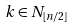Convert formula to latex. <formula><loc_0><loc_0><loc_500><loc_500>k \in N _ { \lfloor n / 2 \rfloor }</formula> 